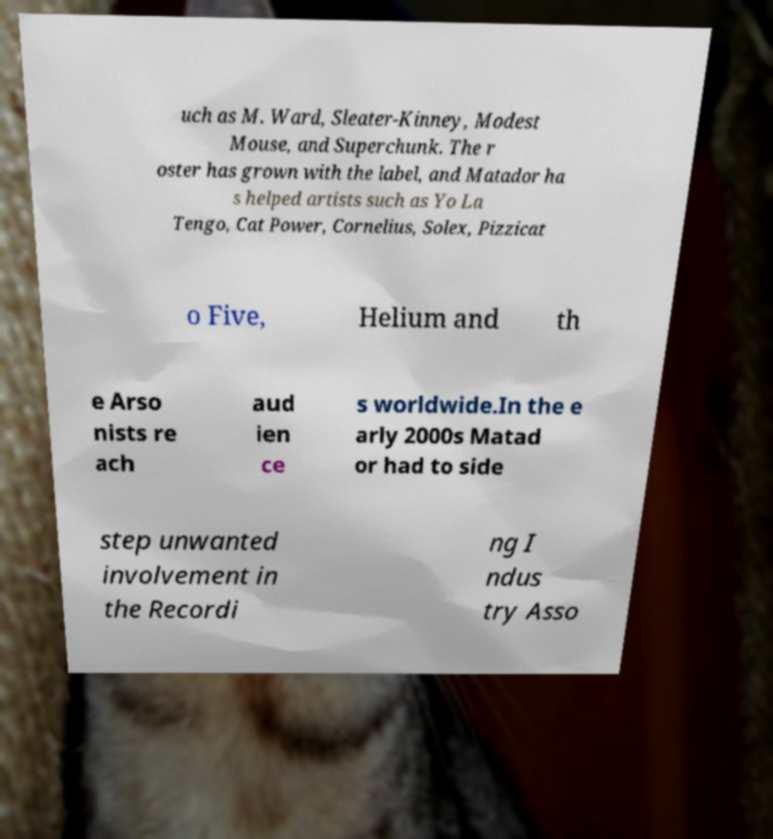Please read and relay the text visible in this image. What does it say? uch as M. Ward, Sleater-Kinney, Modest Mouse, and Superchunk. The r oster has grown with the label, and Matador ha s helped artists such as Yo La Tengo, Cat Power, Cornelius, Solex, Pizzicat o Five, Helium and th e Arso nists re ach aud ien ce s worldwide.In the e arly 2000s Matad or had to side step unwanted involvement in the Recordi ng I ndus try Asso 